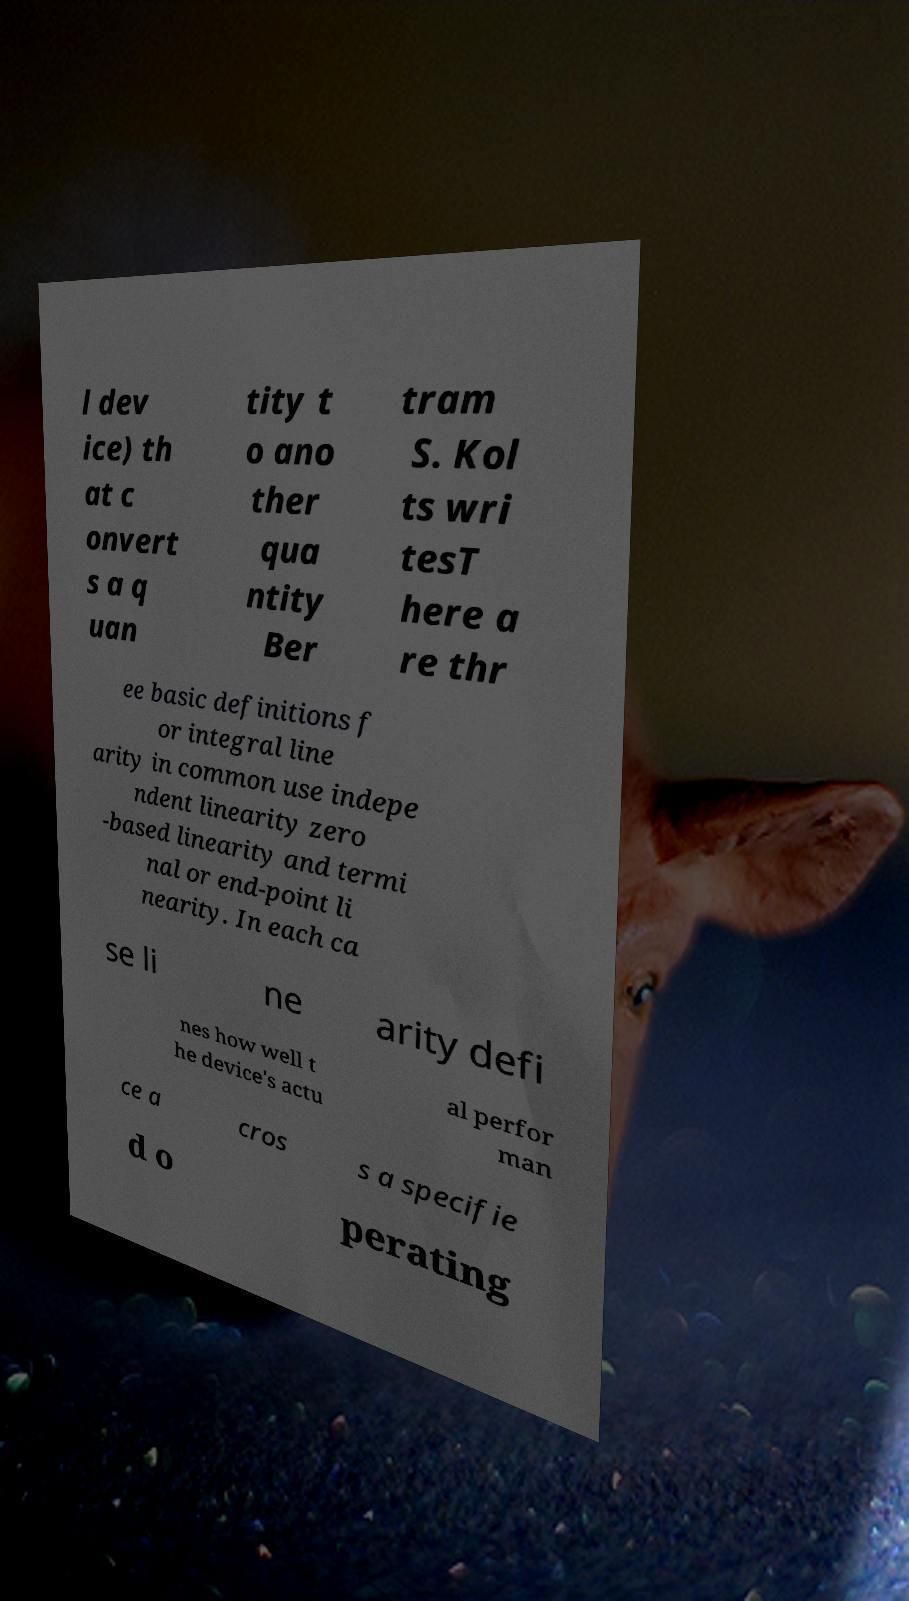Please read and relay the text visible in this image. What does it say? l dev ice) th at c onvert s a q uan tity t o ano ther qua ntity Ber tram S. Kol ts wri tesT here a re thr ee basic definitions f or integral line arity in common use indepe ndent linearity zero -based linearity and termi nal or end-point li nearity. In each ca se li ne arity defi nes how well t he device's actu al perfor man ce a cros s a specifie d o perating 